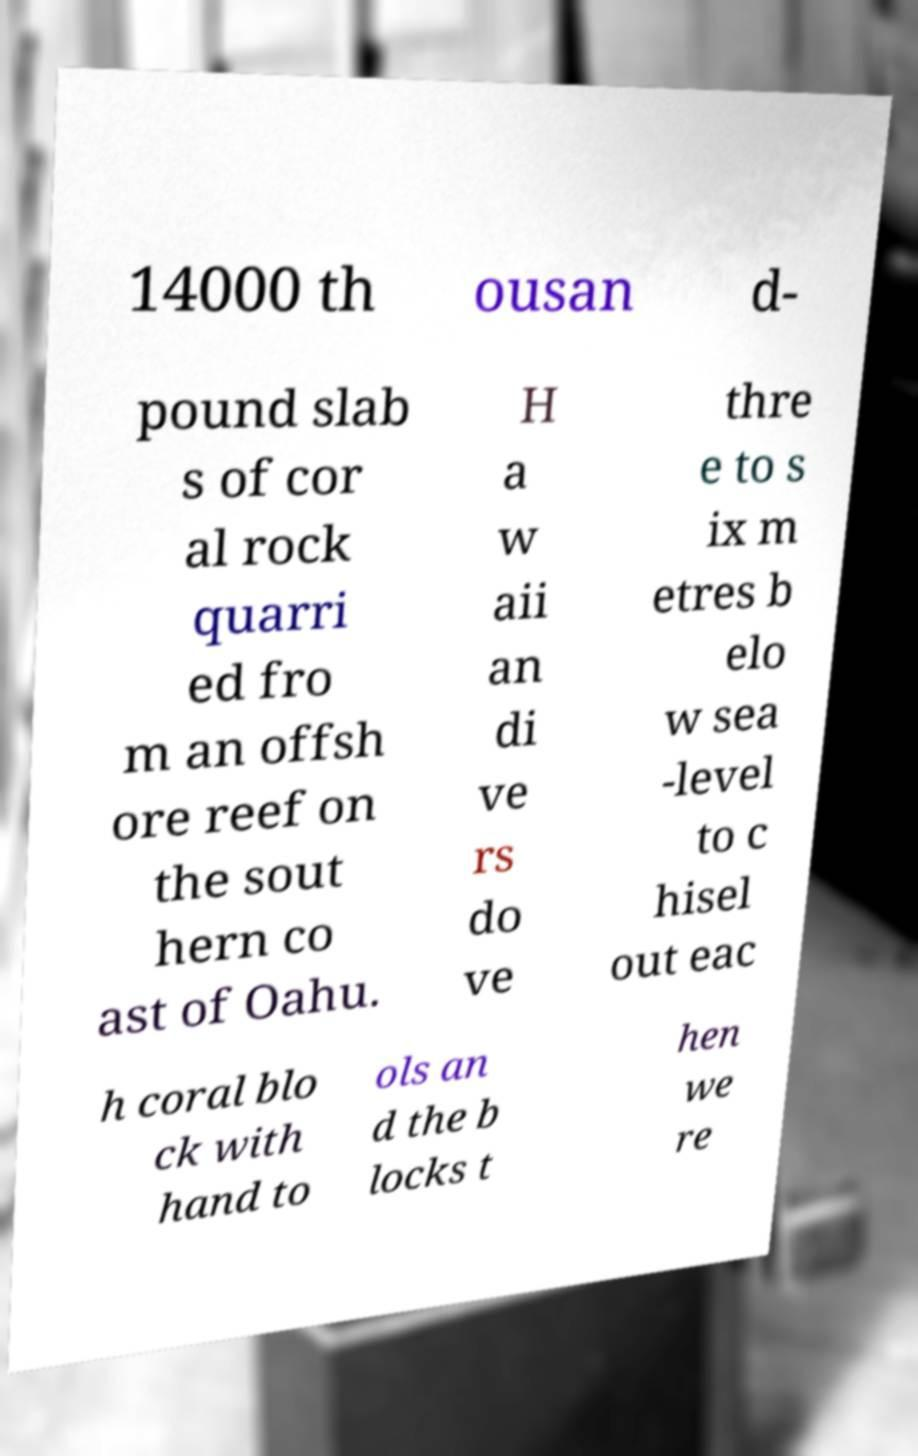What messages or text are displayed in this image? I need them in a readable, typed format. 14000 th ousan d- pound slab s of cor al rock quarri ed fro m an offsh ore reef on the sout hern co ast of Oahu. H a w aii an di ve rs do ve thre e to s ix m etres b elo w sea -level to c hisel out eac h coral blo ck with hand to ols an d the b locks t hen we re 